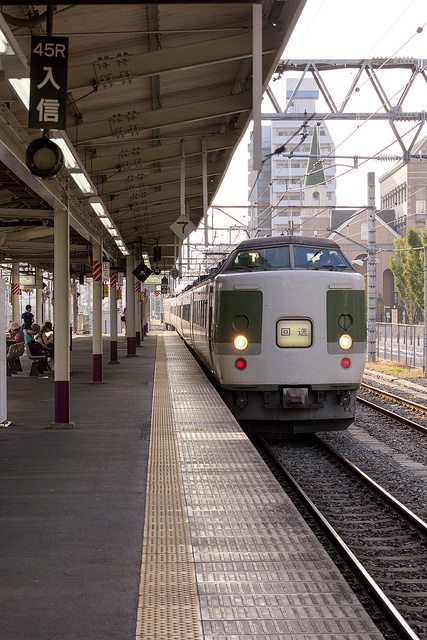Describe the objects in this image and their specific colors. I can see train in black, darkgray, and gray tones, people in black, maroon, teal, and gray tones, bench in black and gray tones, people in black, maroon, and gray tones, and people in black, darkgray, gray, and maroon tones in this image. 